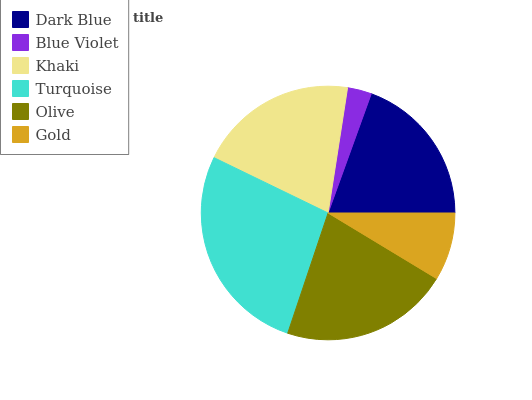Is Blue Violet the minimum?
Answer yes or no. Yes. Is Turquoise the maximum?
Answer yes or no. Yes. Is Khaki the minimum?
Answer yes or no. No. Is Khaki the maximum?
Answer yes or no. No. Is Khaki greater than Blue Violet?
Answer yes or no. Yes. Is Blue Violet less than Khaki?
Answer yes or no. Yes. Is Blue Violet greater than Khaki?
Answer yes or no. No. Is Khaki less than Blue Violet?
Answer yes or no. No. Is Khaki the high median?
Answer yes or no. Yes. Is Dark Blue the low median?
Answer yes or no. Yes. Is Olive the high median?
Answer yes or no. No. Is Blue Violet the low median?
Answer yes or no. No. 